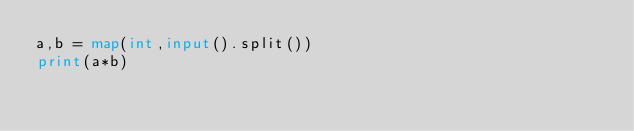<code> <loc_0><loc_0><loc_500><loc_500><_Python_>a,b = map(int,input().split())
print(a*b)</code> 